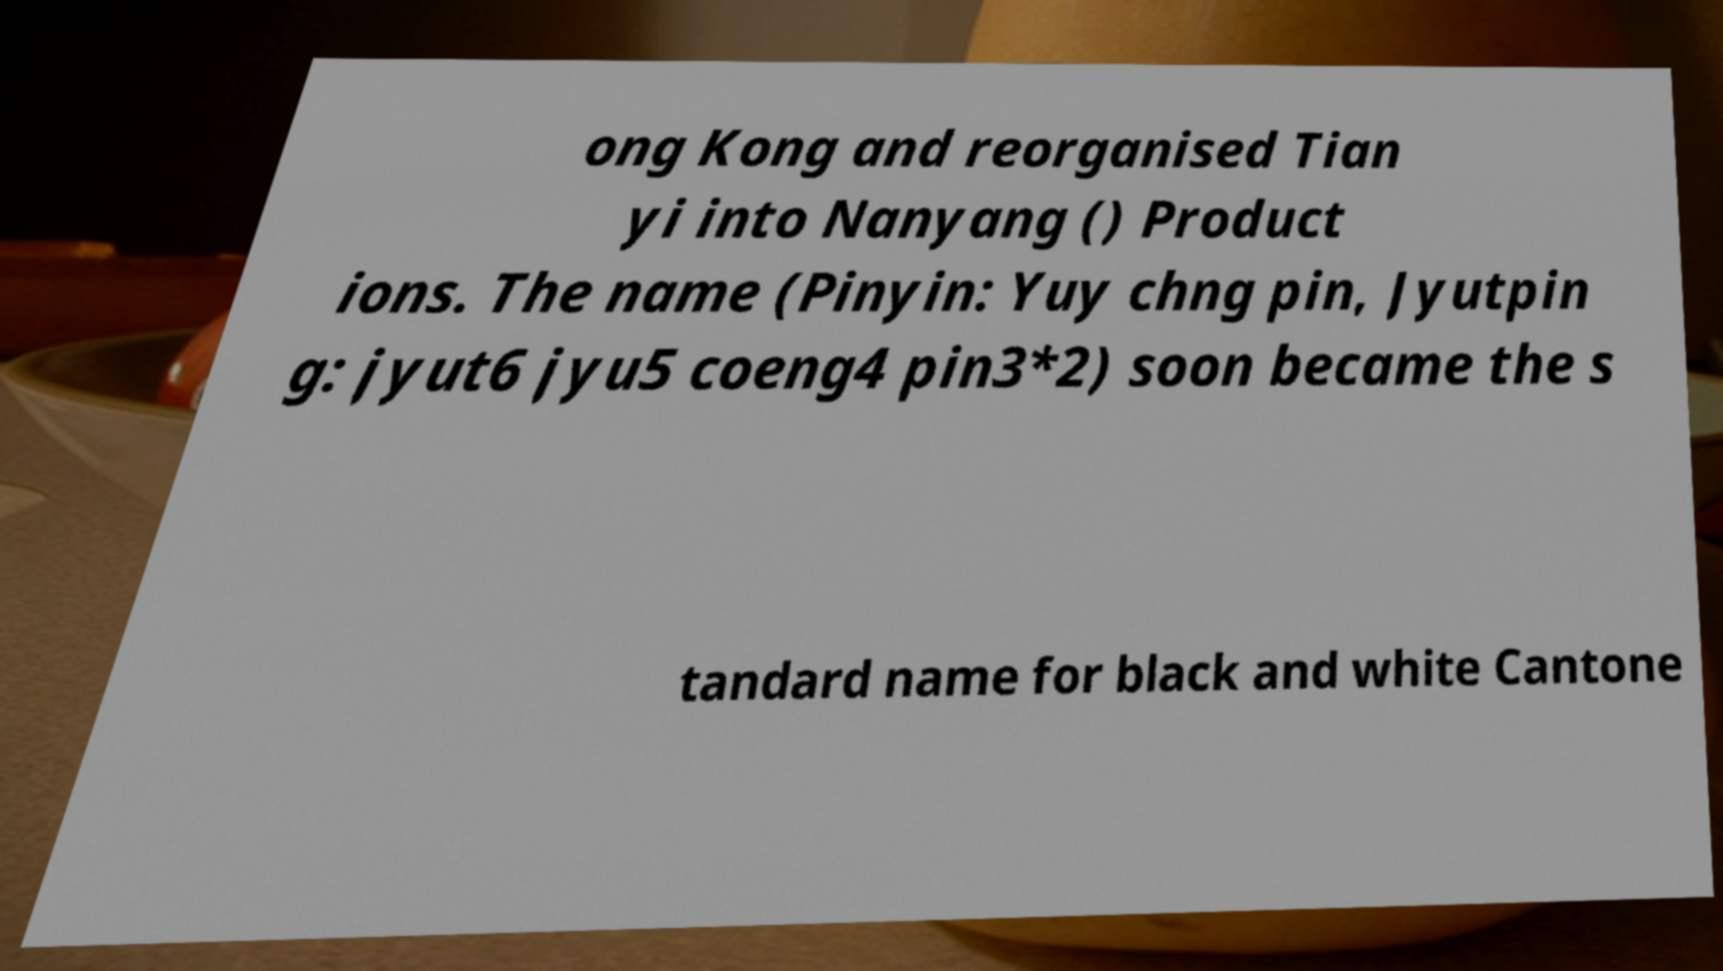Can you accurately transcribe the text from the provided image for me? ong Kong and reorganised Tian yi into Nanyang () Product ions. The name (Pinyin: Yuy chng pin, Jyutpin g: jyut6 jyu5 coeng4 pin3*2) soon became the s tandard name for black and white Cantone 